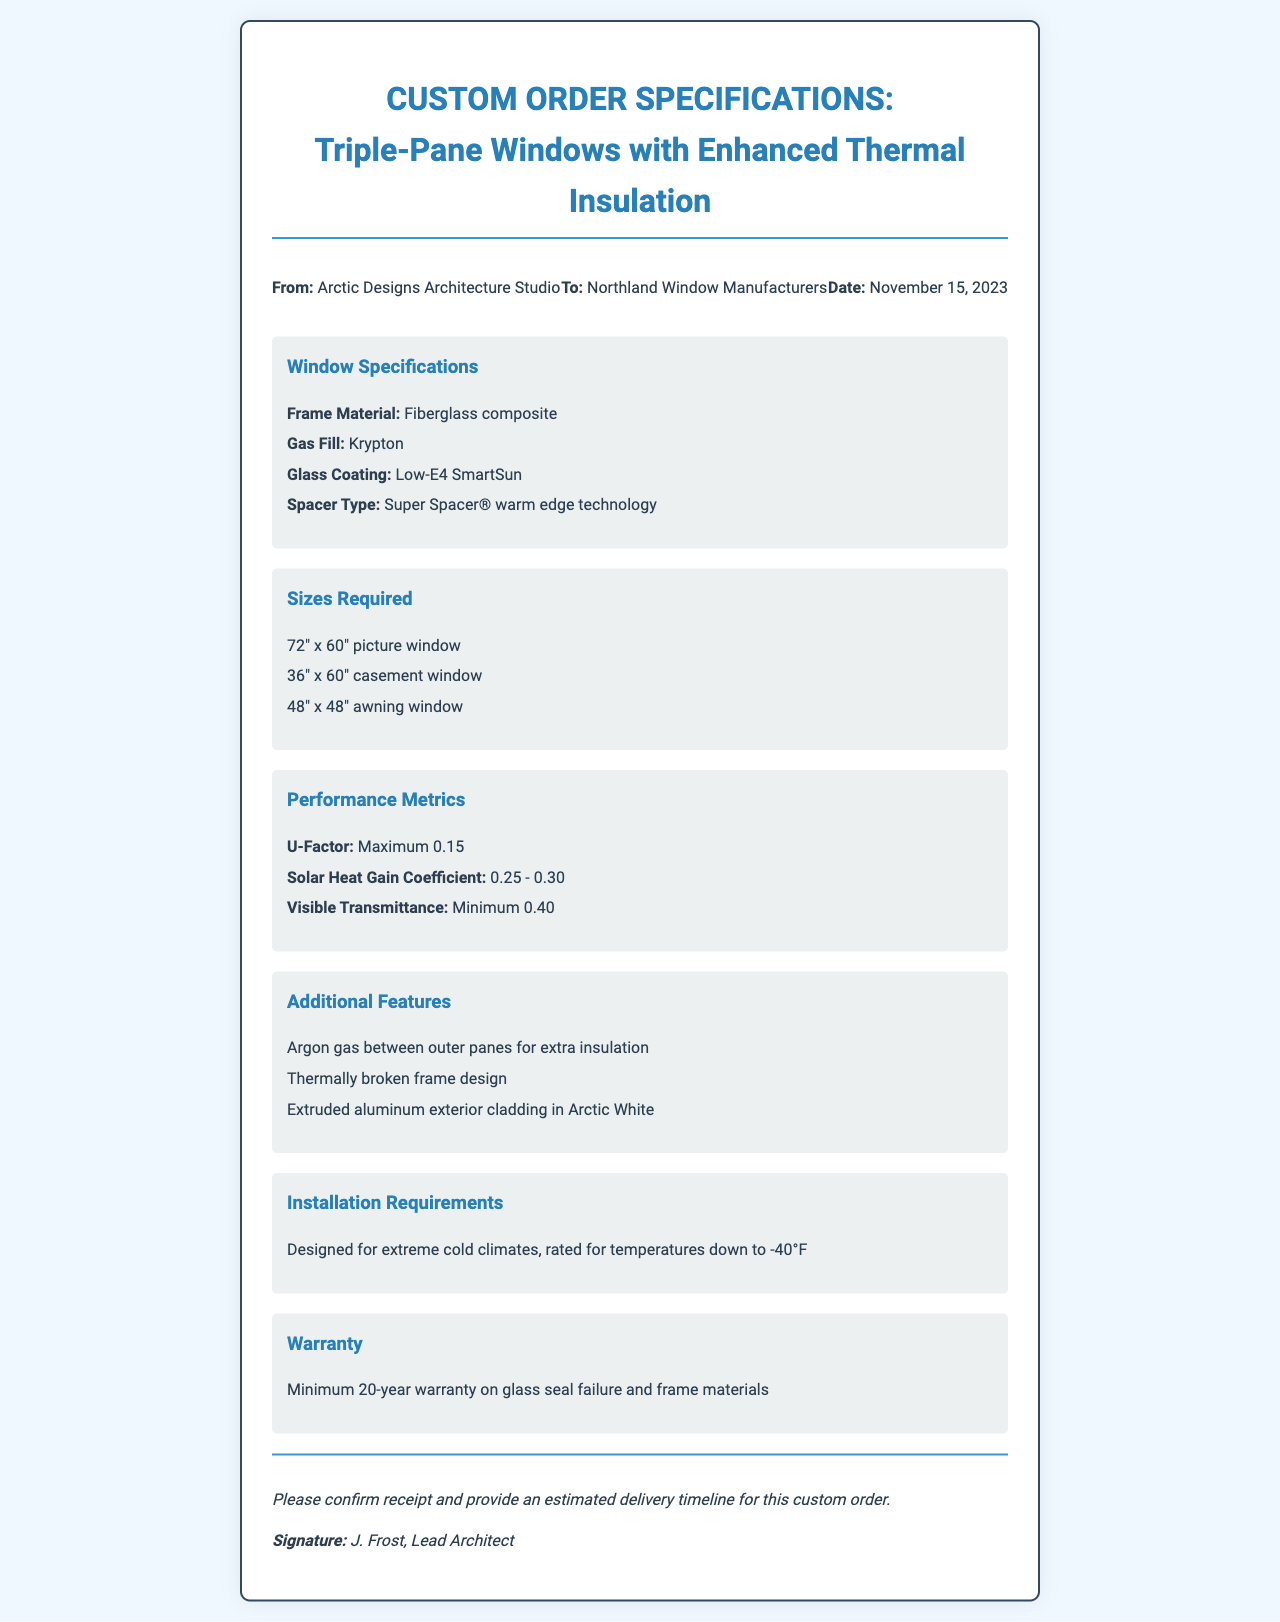What is the frame material? The frame material is specified in the window specifications section of the document.
Answer: Fiberglass composite What is the U-Factor maximum? The U-Factor maximum is stated under performance metrics.
Answer: 0.15 What is the size of the picture window? The size of the picture window is listed in the sizes required section.
Answer: 72" x 60" What warranty is mentioned? The warranty is detailed in the warranty section of the document.
Answer: Minimum 20-year warranty What type of gas is used for fill? The type of gas fill is indicated in the window specifications section.
Answer: Krypton What is the temperature rating for installation? The temperature rating for installation requirements is provided in the installation section.
Answer: -40°F How many different window sizes are specified? The different sizes of windows listed provide insight into the quantity specified in the document.
Answer: Three What color is the exterior cladding? The color of the exterior cladding is mentioned in the additional features section.
Answer: Arctic White What is the Solar Heat Gain Coefficient range? The range for Solar Heat Gain Coefficient is provided under performance metrics.
Answer: 0.25 - 0.30 